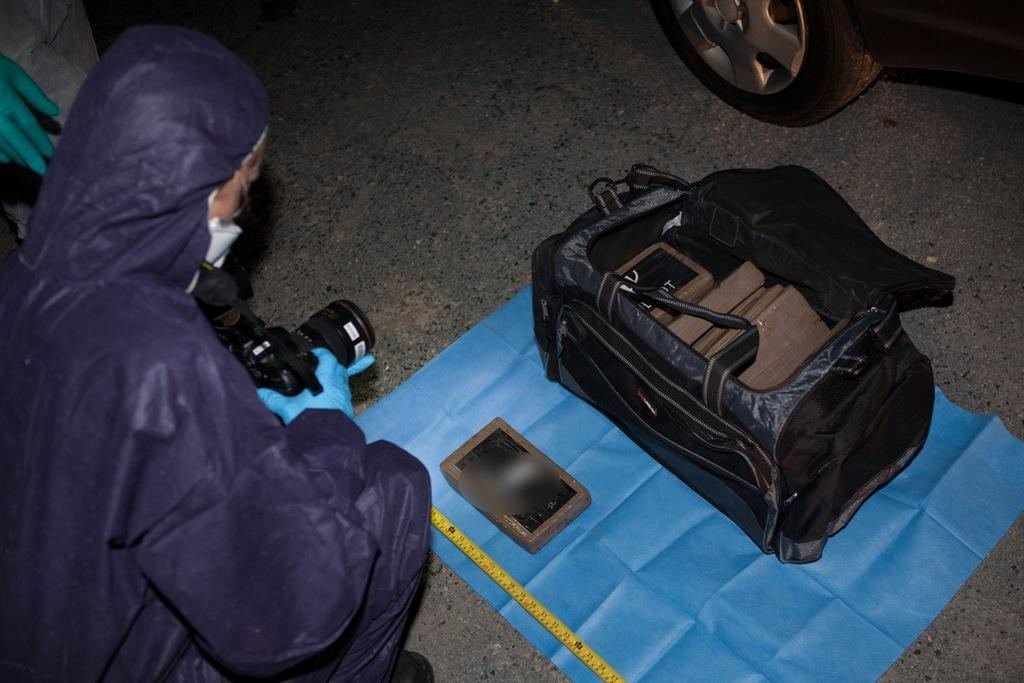What is the person on the left side of the image doing? The person is sitting and holding a camera. What objects are in the center of the image? There are boxes, a scale, a bag, and cloth in the center of the image. What is located on the top right side of the image? There is a vehicle on the top right side of the image. Can you see any stamps on the boxes in the image? There is no mention of stamps on the boxes in the image, so we cannot determine if any are present. What type of chalk is being used by the person holding the camera? There is no chalk present in the image, as the person is holding a camera. 